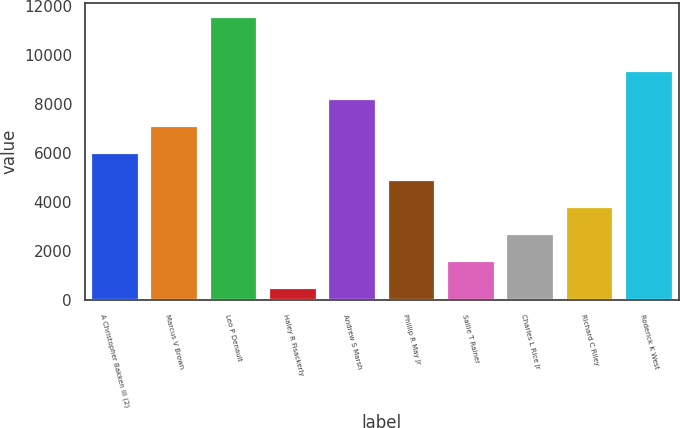Convert chart. <chart><loc_0><loc_0><loc_500><loc_500><bar_chart><fcel>A Christopher Bakken III (2)<fcel>Marcus V Brown<fcel>Leo P Denault<fcel>Haley R Fisackerly<fcel>Andrew S Marsh<fcel>Phillip R May Jr<fcel>Sallie T Rainer<fcel>Charles L Rice Jr<fcel>Richard C Riley<fcel>Roderick K West<nl><fcel>6030<fcel>7134.8<fcel>11554<fcel>506<fcel>8239.6<fcel>4925.2<fcel>1610.8<fcel>2715.6<fcel>3820.4<fcel>9344.4<nl></chart> 